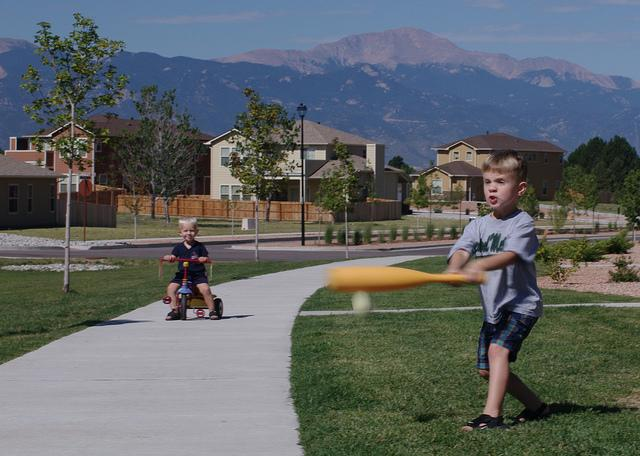What is the child travelling on?

Choices:
A) hummer
B) tricycle
C) monster truck
D) tank tricycle 